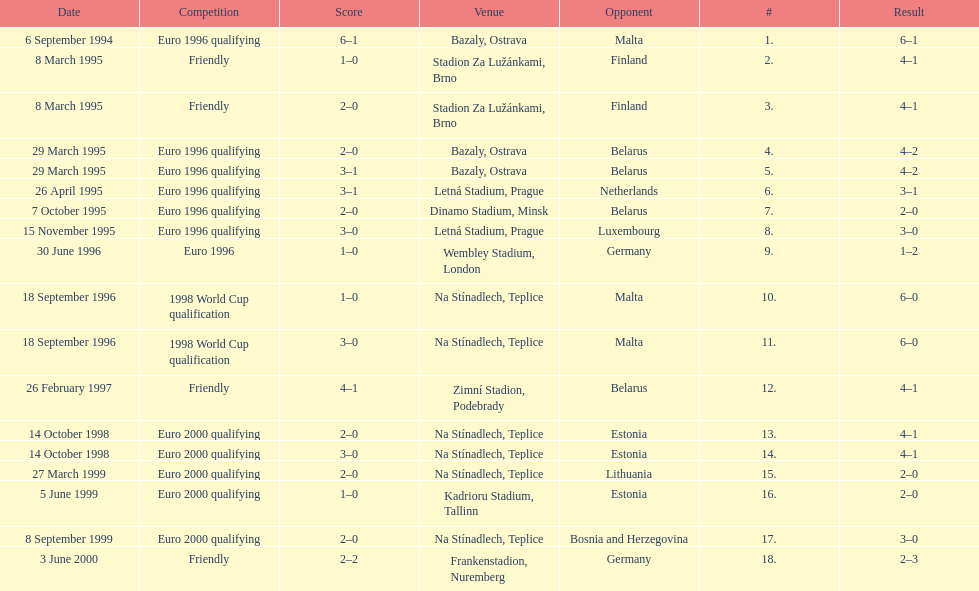Which team did czech republic score the most goals against? Malta. Parse the table in full. {'header': ['Date', 'Competition', 'Score', 'Venue', 'Opponent', '#', 'Result'], 'rows': [['6 September 1994', 'Euro 1996 qualifying', '6–1', 'Bazaly, Ostrava', 'Malta', '1.', '6–1'], ['8 March 1995', 'Friendly', '1–0', 'Stadion Za Lužánkami, Brno', 'Finland', '2.', '4–1'], ['8 March 1995', 'Friendly', '2–0', 'Stadion Za Lužánkami, Brno', 'Finland', '3.', '4–1'], ['29 March 1995', 'Euro 1996 qualifying', '2–0', 'Bazaly, Ostrava', 'Belarus', '4.', '4–2'], ['29 March 1995', 'Euro 1996 qualifying', '3–1', 'Bazaly, Ostrava', 'Belarus', '5.', '4–2'], ['26 April 1995', 'Euro 1996 qualifying', '3–1', 'Letná Stadium, Prague', 'Netherlands', '6.', '3–1'], ['7 October 1995', 'Euro 1996 qualifying', '2–0', 'Dinamo Stadium, Minsk', 'Belarus', '7.', '2–0'], ['15 November 1995', 'Euro 1996 qualifying', '3–0', 'Letná Stadium, Prague', 'Luxembourg', '8.', '3–0'], ['30 June 1996', 'Euro 1996', '1–0', 'Wembley Stadium, London', 'Germany', '9.', '1–2'], ['18 September 1996', '1998 World Cup qualification', '1–0', 'Na Stínadlech, Teplice', 'Malta', '10.', '6–0'], ['18 September 1996', '1998 World Cup qualification', '3–0', 'Na Stínadlech, Teplice', 'Malta', '11.', '6–0'], ['26 February 1997', 'Friendly', '4–1', 'Zimní Stadion, Podebrady', 'Belarus', '12.', '4–1'], ['14 October 1998', 'Euro 2000 qualifying', '2–0', 'Na Stínadlech, Teplice', 'Estonia', '13.', '4–1'], ['14 October 1998', 'Euro 2000 qualifying', '3–0', 'Na Stínadlech, Teplice', 'Estonia', '14.', '4–1'], ['27 March 1999', 'Euro 2000 qualifying', '2–0', 'Na Stínadlech, Teplice', 'Lithuania', '15.', '2–0'], ['5 June 1999', 'Euro 2000 qualifying', '1–0', 'Kadrioru Stadium, Tallinn', 'Estonia', '16.', '2–0'], ['8 September 1999', 'Euro 2000 qualifying', '2–0', 'Na Stínadlech, Teplice', 'Bosnia and Herzegovina', '17.', '3–0'], ['3 June 2000', 'Friendly', '2–2', 'Frankenstadion, Nuremberg', 'Germany', '18.', '2–3']]} 